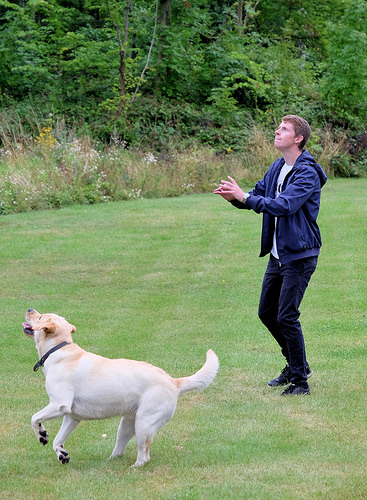<image>
Is there a dog behind the man? No. The dog is not behind the man. From this viewpoint, the dog appears to be positioned elsewhere in the scene. Is there a dog in front of the man? Yes. The dog is positioned in front of the man, appearing closer to the camera viewpoint. 